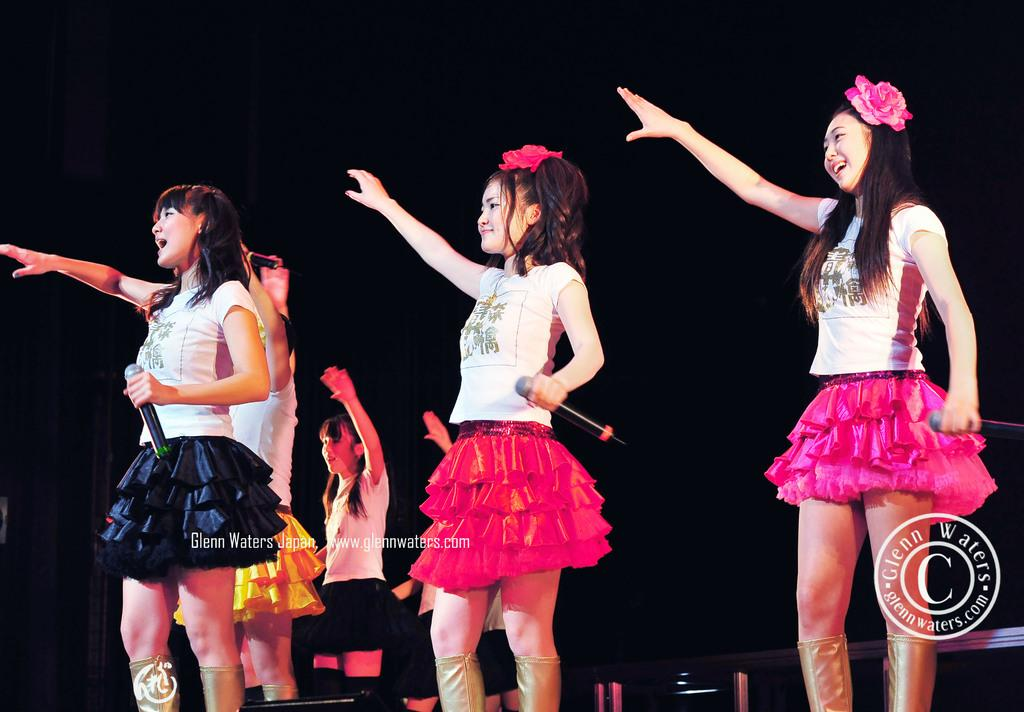How many people are in the image? There are three girls in the image. What are the girls doing in the image? The girls are standing and holding microphones. What can be observed about the background of the image? The background of the image is dark. Where is the basket located in the image? There is no basket present in the image. What type of alley can be seen in the image? There is no alley present in the image. 